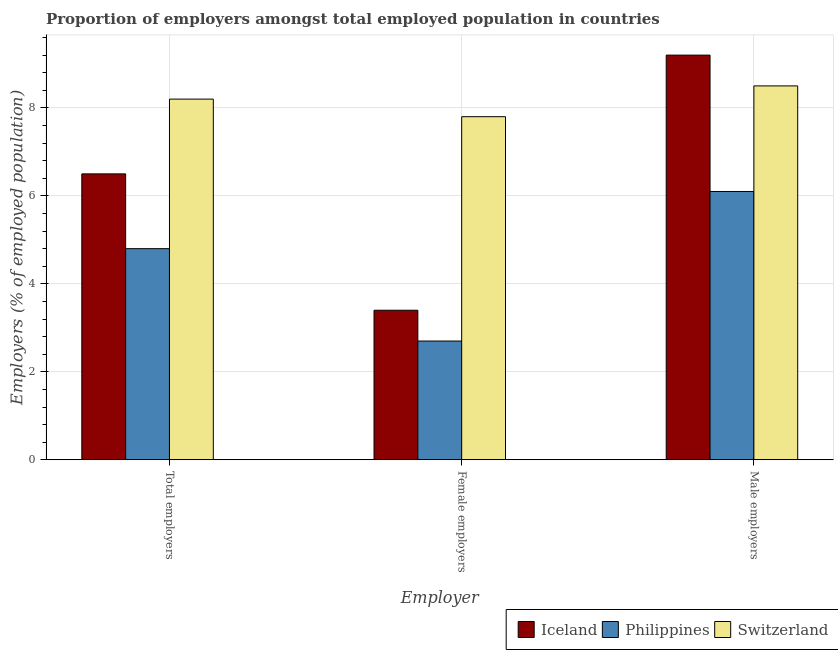Are the number of bars per tick equal to the number of legend labels?
Provide a short and direct response. Yes. Are the number of bars on each tick of the X-axis equal?
Your response must be concise. Yes. How many bars are there on the 1st tick from the left?
Give a very brief answer. 3. How many bars are there on the 1st tick from the right?
Keep it short and to the point. 3. What is the label of the 1st group of bars from the left?
Your response must be concise. Total employers. What is the percentage of male employers in Philippines?
Give a very brief answer. 6.1. Across all countries, what is the maximum percentage of female employers?
Make the answer very short. 7.8. Across all countries, what is the minimum percentage of female employers?
Give a very brief answer. 2.7. In which country was the percentage of female employers minimum?
Your answer should be very brief. Philippines. What is the difference between the percentage of total employers in Iceland and that in Switzerland?
Provide a short and direct response. -1.7. What is the difference between the percentage of female employers in Iceland and the percentage of male employers in Philippines?
Give a very brief answer. -2.7. What is the average percentage of female employers per country?
Your answer should be very brief. 4.63. What is the difference between the percentage of male employers and percentage of female employers in Iceland?
Your answer should be compact. 5.8. What is the ratio of the percentage of total employers in Switzerland to that in Iceland?
Provide a short and direct response. 1.26. What is the difference between the highest and the second highest percentage of male employers?
Provide a succinct answer. 0.7. What is the difference between the highest and the lowest percentage of male employers?
Offer a terse response. 3.1. In how many countries, is the percentage of total employers greater than the average percentage of total employers taken over all countries?
Provide a short and direct response. 1. Is the sum of the percentage of total employers in Philippines and Iceland greater than the maximum percentage of female employers across all countries?
Provide a short and direct response. Yes. What does the 2nd bar from the left in Female employers represents?
Provide a succinct answer. Philippines. What is the difference between two consecutive major ticks on the Y-axis?
Provide a succinct answer. 2. Does the graph contain any zero values?
Make the answer very short. No. Does the graph contain grids?
Ensure brevity in your answer.  Yes. Where does the legend appear in the graph?
Your response must be concise. Bottom right. How many legend labels are there?
Give a very brief answer. 3. How are the legend labels stacked?
Ensure brevity in your answer.  Horizontal. What is the title of the graph?
Your response must be concise. Proportion of employers amongst total employed population in countries. Does "St. Vincent and the Grenadines" appear as one of the legend labels in the graph?
Give a very brief answer. No. What is the label or title of the X-axis?
Provide a short and direct response. Employer. What is the label or title of the Y-axis?
Ensure brevity in your answer.  Employers (% of employed population). What is the Employers (% of employed population) of Philippines in Total employers?
Offer a terse response. 4.8. What is the Employers (% of employed population) in Switzerland in Total employers?
Provide a short and direct response. 8.2. What is the Employers (% of employed population) of Iceland in Female employers?
Offer a very short reply. 3.4. What is the Employers (% of employed population) in Philippines in Female employers?
Your response must be concise. 2.7. What is the Employers (% of employed population) in Switzerland in Female employers?
Your answer should be very brief. 7.8. What is the Employers (% of employed population) of Iceland in Male employers?
Keep it short and to the point. 9.2. What is the Employers (% of employed population) of Philippines in Male employers?
Your answer should be compact. 6.1. What is the Employers (% of employed population) in Switzerland in Male employers?
Offer a very short reply. 8.5. Across all Employer, what is the maximum Employers (% of employed population) in Iceland?
Offer a terse response. 9.2. Across all Employer, what is the maximum Employers (% of employed population) of Philippines?
Your answer should be compact. 6.1. Across all Employer, what is the minimum Employers (% of employed population) of Iceland?
Give a very brief answer. 3.4. Across all Employer, what is the minimum Employers (% of employed population) in Philippines?
Your response must be concise. 2.7. Across all Employer, what is the minimum Employers (% of employed population) in Switzerland?
Provide a short and direct response. 7.8. What is the total Employers (% of employed population) in Iceland in the graph?
Keep it short and to the point. 19.1. What is the difference between the Employers (% of employed population) in Iceland in Total employers and that in Female employers?
Your answer should be compact. 3.1. What is the difference between the Employers (% of employed population) of Switzerland in Total employers and that in Female employers?
Ensure brevity in your answer.  0.4. What is the difference between the Employers (% of employed population) in Iceland in Total employers and that in Male employers?
Ensure brevity in your answer.  -2.7. What is the difference between the Employers (% of employed population) of Iceland in Female employers and that in Male employers?
Provide a short and direct response. -5.8. What is the difference between the Employers (% of employed population) in Philippines in Female employers and that in Male employers?
Provide a succinct answer. -3.4. What is the difference between the Employers (% of employed population) of Switzerland in Female employers and that in Male employers?
Offer a terse response. -0.7. What is the difference between the Employers (% of employed population) in Iceland in Total employers and the Employers (% of employed population) in Switzerland in Female employers?
Provide a succinct answer. -1.3. What is the difference between the Employers (% of employed population) of Philippines in Total employers and the Employers (% of employed population) of Switzerland in Female employers?
Ensure brevity in your answer.  -3. What is the difference between the Employers (% of employed population) in Iceland in Total employers and the Employers (% of employed population) in Philippines in Male employers?
Your response must be concise. 0.4. What is the difference between the Employers (% of employed population) in Iceland in Total employers and the Employers (% of employed population) in Switzerland in Male employers?
Give a very brief answer. -2. What is the difference between the Employers (% of employed population) in Philippines in Total employers and the Employers (% of employed population) in Switzerland in Male employers?
Ensure brevity in your answer.  -3.7. What is the difference between the Employers (% of employed population) in Philippines in Female employers and the Employers (% of employed population) in Switzerland in Male employers?
Give a very brief answer. -5.8. What is the average Employers (% of employed population) of Iceland per Employer?
Provide a succinct answer. 6.37. What is the average Employers (% of employed population) in Philippines per Employer?
Your answer should be compact. 4.53. What is the average Employers (% of employed population) in Switzerland per Employer?
Give a very brief answer. 8.17. What is the difference between the Employers (% of employed population) of Iceland and Employers (% of employed population) of Philippines in Total employers?
Ensure brevity in your answer.  1.7. What is the difference between the Employers (% of employed population) of Iceland and Employers (% of employed population) of Switzerland in Total employers?
Provide a succinct answer. -1.7. What is the difference between the Employers (% of employed population) in Philippines and Employers (% of employed population) in Switzerland in Total employers?
Make the answer very short. -3.4. What is the difference between the Employers (% of employed population) of Iceland and Employers (% of employed population) of Philippines in Female employers?
Make the answer very short. 0.7. What is the difference between the Employers (% of employed population) of Iceland and Employers (% of employed population) of Switzerland in Female employers?
Provide a succinct answer. -4.4. What is the difference between the Employers (% of employed population) of Iceland and Employers (% of employed population) of Philippines in Male employers?
Provide a succinct answer. 3.1. What is the ratio of the Employers (% of employed population) of Iceland in Total employers to that in Female employers?
Keep it short and to the point. 1.91. What is the ratio of the Employers (% of employed population) of Philippines in Total employers to that in Female employers?
Provide a succinct answer. 1.78. What is the ratio of the Employers (% of employed population) in Switzerland in Total employers to that in Female employers?
Provide a succinct answer. 1.05. What is the ratio of the Employers (% of employed population) of Iceland in Total employers to that in Male employers?
Your response must be concise. 0.71. What is the ratio of the Employers (% of employed population) of Philippines in Total employers to that in Male employers?
Offer a terse response. 0.79. What is the ratio of the Employers (% of employed population) of Switzerland in Total employers to that in Male employers?
Give a very brief answer. 0.96. What is the ratio of the Employers (% of employed population) of Iceland in Female employers to that in Male employers?
Ensure brevity in your answer.  0.37. What is the ratio of the Employers (% of employed population) of Philippines in Female employers to that in Male employers?
Your answer should be very brief. 0.44. What is the ratio of the Employers (% of employed population) in Switzerland in Female employers to that in Male employers?
Keep it short and to the point. 0.92. What is the difference between the highest and the second highest Employers (% of employed population) of Switzerland?
Give a very brief answer. 0.3. What is the difference between the highest and the lowest Employers (% of employed population) of Philippines?
Provide a short and direct response. 3.4. What is the difference between the highest and the lowest Employers (% of employed population) in Switzerland?
Give a very brief answer. 0.7. 